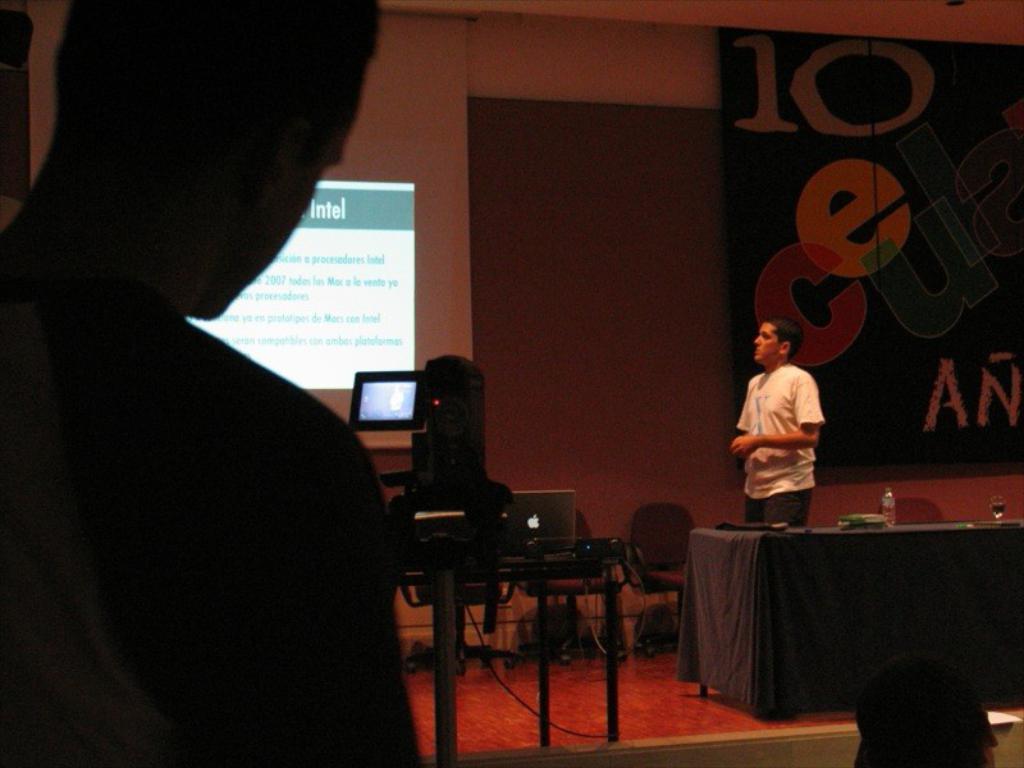How would you summarize this image in a sentence or two? In this image we can see a person standing on the stage. Beside him there are chairs, laptop and camera. We can see a LCD screen at the background. There are two people at front of the image and on stage there is a table where water bottle and glass where placed on it. 